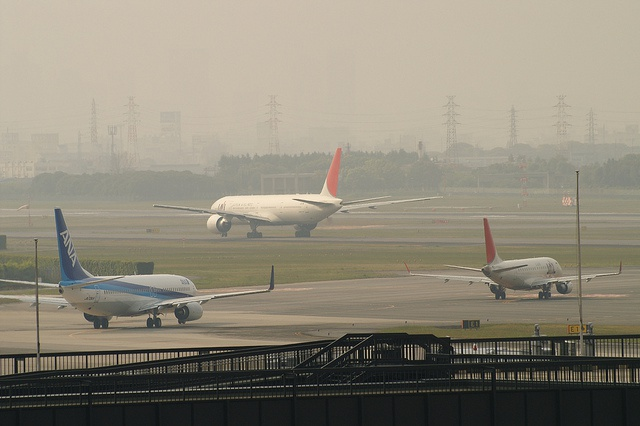Describe the objects in this image and their specific colors. I can see airplane in lightgray, gray, darkgray, and blue tones, airplane in lightgray, darkgray, gray, and beige tones, and airplane in lightgray, gray, and darkgray tones in this image. 